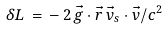Convert formula to latex. <formula><loc_0><loc_0><loc_500><loc_500>\delta L \, = \, - \, 2 \, \vec { g } \cdot \vec { r } \, \vec { v } _ { s } \cdot \vec { v } / c ^ { 2 }</formula> 